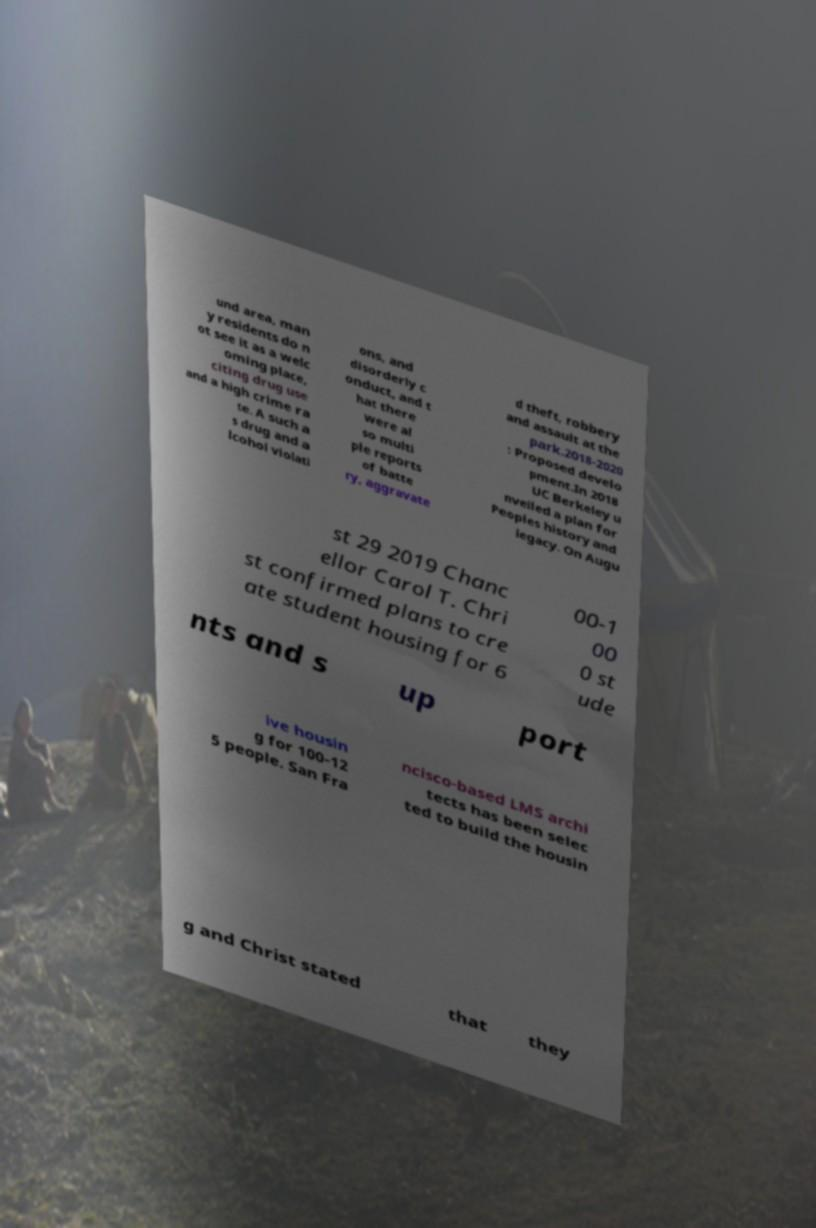Can you accurately transcribe the text from the provided image for me? und area, man y residents do n ot see it as a welc oming place, citing drug use and a high crime ra te. A such a s drug and a lcohol violati ons, and disorderly c onduct, and t hat there were al so multi ple reports of batte ry, aggravate d theft, robbery and assault at the park.2018-2020 : Proposed develo pment.In 2018 UC Berkeley u nveiled a plan for Peoples history and legacy. On Augu st 29 2019 Chanc ellor Carol T. Chri st confirmed plans to cre ate student housing for 6 00-1 00 0 st ude nts and s up port ive housin g for 100-12 5 people. San Fra ncisco-based LMS archi tects has been selec ted to build the housin g and Christ stated that they 